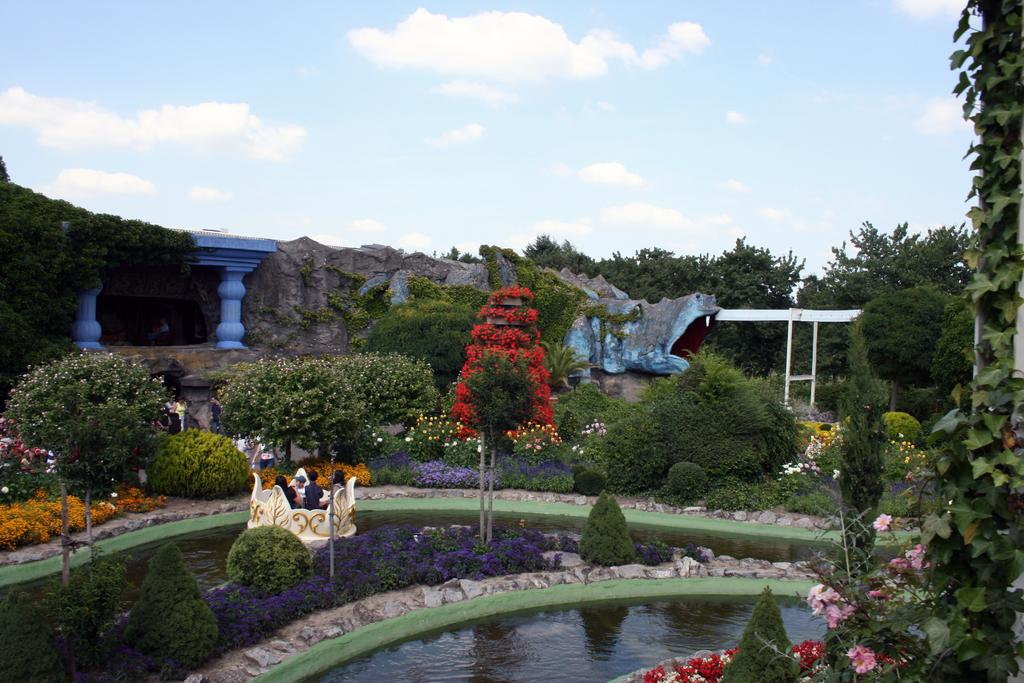What is the primary element in the image? There is water in the image. What types of vegetation can be seen in the image? There are plants, trees, and flowers in the image. Where are the people located in the image? The people are in the center of the image. What is visible in the background of the image? There are clouds and the sky visible in the background of the image. What is the best way to roll the edge of the water in the image? There is no edge to the water in the image, as it is a continuous body of water. 